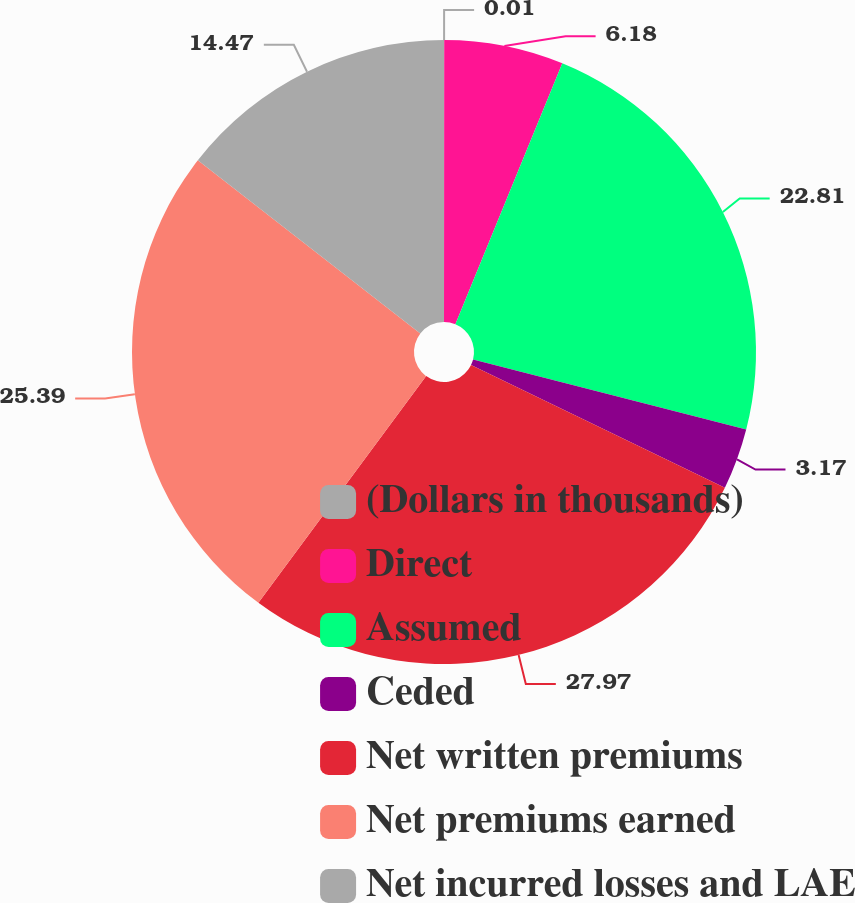Convert chart to OTSL. <chart><loc_0><loc_0><loc_500><loc_500><pie_chart><fcel>(Dollars in thousands)<fcel>Direct<fcel>Assumed<fcel>Ceded<fcel>Net written premiums<fcel>Net premiums earned<fcel>Net incurred losses and LAE<nl><fcel>0.01%<fcel>6.18%<fcel>22.81%<fcel>3.17%<fcel>27.97%<fcel>25.39%<fcel>14.47%<nl></chart> 